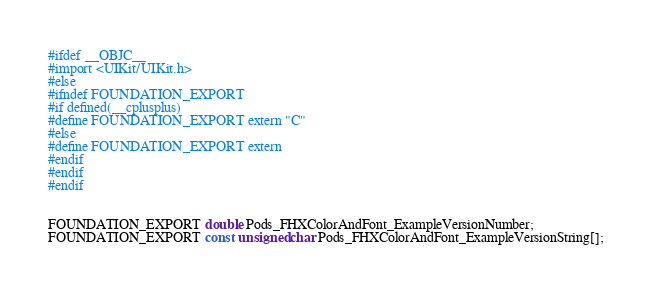<code> <loc_0><loc_0><loc_500><loc_500><_C_>#ifdef __OBJC__
#import <UIKit/UIKit.h>
#else
#ifndef FOUNDATION_EXPORT
#if defined(__cplusplus)
#define FOUNDATION_EXPORT extern "C"
#else
#define FOUNDATION_EXPORT extern
#endif
#endif
#endif


FOUNDATION_EXPORT double Pods_FHXColorAndFont_ExampleVersionNumber;
FOUNDATION_EXPORT const unsigned char Pods_FHXColorAndFont_ExampleVersionString[];

</code> 